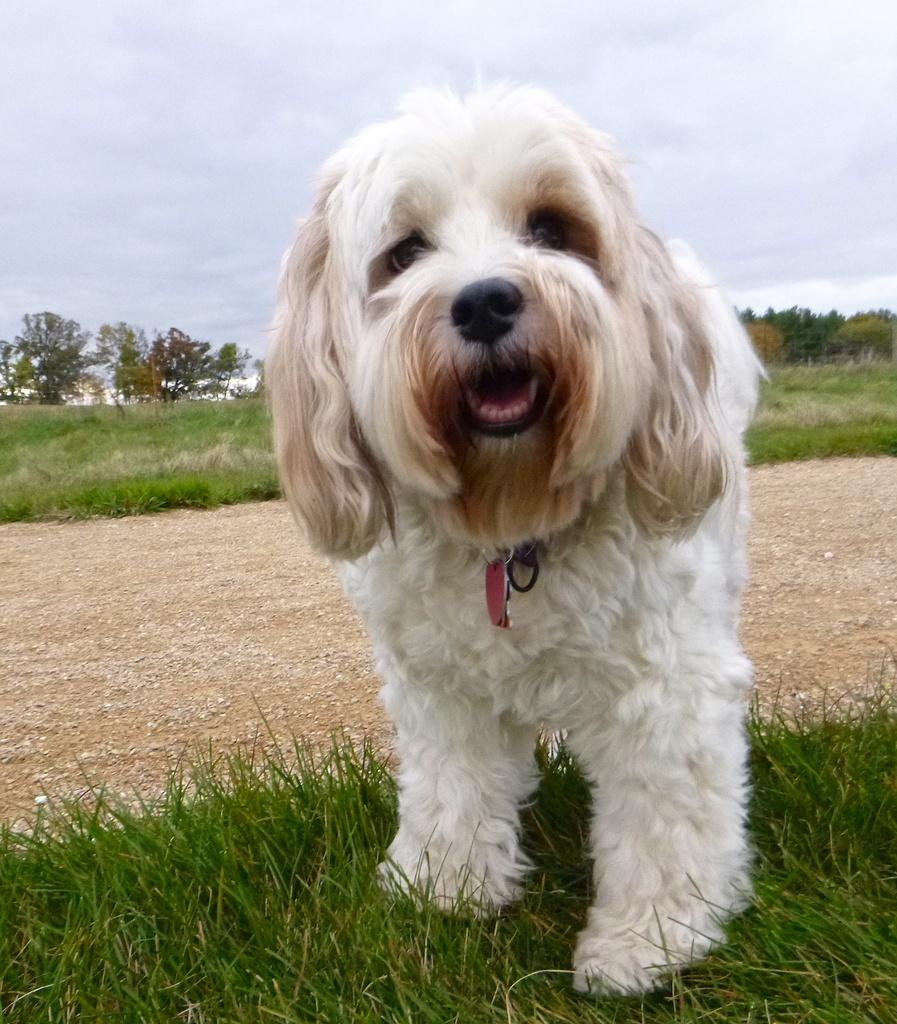What type of vegetation can be seen in the image? There is grass in the image. What other natural elements are present in the image? There are trees and clouds visible in the image. What is the color of the sky in the image? The sky is visible in the image. Can you describe the dog in the image? There is a white-colored dog standing in the image. What is the color of the red-colored object in the image? There is a red-colored object in the image. What is the aftermath of the storm in the image? There is no mention of a storm or any aftermath in the image. How many clouds are visible in the image? The number of clouds cannot be definitively determined from the image. 